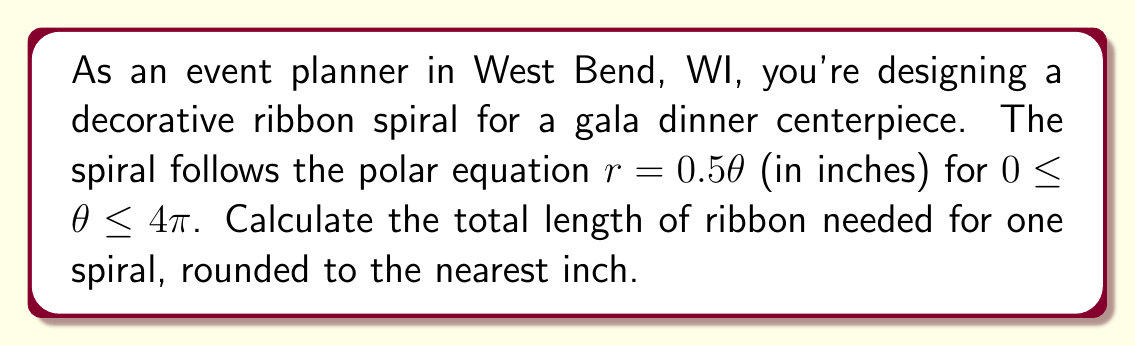Help me with this question. To find the length of the polar curve, we'll use the arc length formula for polar curves:

$$L = \int_{a}^{b} \sqrt{r^2 + \left(\frac{dr}{d\theta}\right)^2} d\theta$$

For our spiral, $r = 0.5\theta$ and $\frac{dr}{d\theta} = 0.5$

Step 1: Substitute these into the formula:
$$L = \int_{0}^{4\pi} \sqrt{(0.5\theta)^2 + (0.5)^2} d\theta$$

Step 2: Simplify under the square root:
$$L = \int_{0}^{4\pi} \sqrt{0.25\theta^2 + 0.25} d\theta$$
$$L = 0.5 \int_{0}^{4\pi} \sqrt{\theta^2 + 1} d\theta$$

Step 3: This integral doesn't have an elementary antiderivative. We can solve it using the substitution $\theta = \sinh u$:

$$L = 0.5 \int_{0}^{\sinh^{-1}(4\pi)} \sqrt{\sinh^2 u + 1} \cosh u du$$

Step 4: Simplify using the identity $\sinh^2 u + 1 = \cosh^2 u$:

$$L = 0.5 \int_{0}^{\sinh^{-1}(4\pi)} \cosh^2 u du$$

Step 5: Use the identity $\cosh^2 u = \frac{1}{2}(\cosh 2u + 1)$:

$$L = 0.25 \int_{0}^{\sinh^{-1}(4\pi)} (\cosh 2u + 1) du$$

Step 6: Integrate:

$$L = 0.25 \left[\frac{1}{2}\sinh 2u + u\right]_{0}^{\sinh^{-1}(4\pi)}$$

Step 7: Evaluate the integral:

$$L = 0.25 \left[\frac{1}{2}\sinh(2\sinh^{-1}(4\pi)) + \sinh^{-1}(4\pi)\right]$$

Step 8: Simplify using $\sinh(2\sinh^{-1}(x)) = 2x\sqrt{1+x^2}$:

$$L = 0.25 \left[4\pi\sqrt{1+(4\pi)^2} + \sinh^{-1}(4\pi)\right]$$

Step 9: Calculate the numerical value and round to the nearest inch:

$$L \approx 25.13 \text{ inches}$$
Answer: 25 inches 